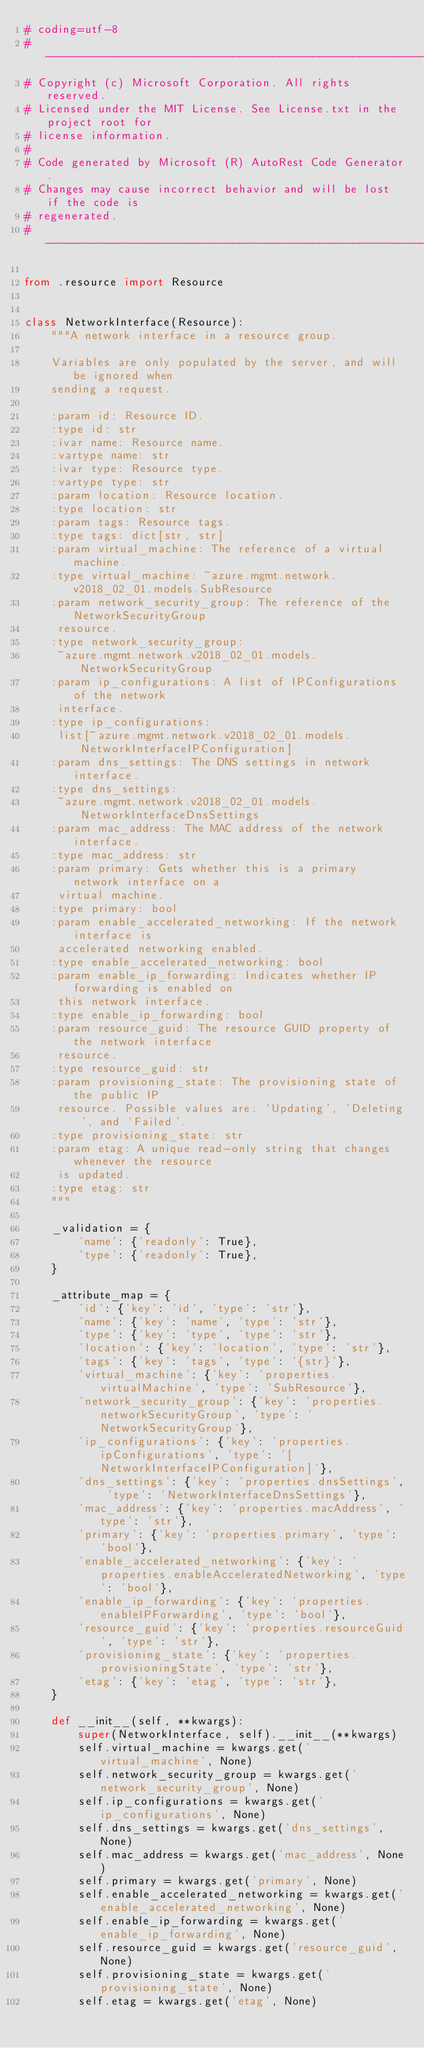Convert code to text. <code><loc_0><loc_0><loc_500><loc_500><_Python_># coding=utf-8
# --------------------------------------------------------------------------
# Copyright (c) Microsoft Corporation. All rights reserved.
# Licensed under the MIT License. See License.txt in the project root for
# license information.
#
# Code generated by Microsoft (R) AutoRest Code Generator.
# Changes may cause incorrect behavior and will be lost if the code is
# regenerated.
# --------------------------------------------------------------------------

from .resource import Resource


class NetworkInterface(Resource):
    """A network interface in a resource group.

    Variables are only populated by the server, and will be ignored when
    sending a request.

    :param id: Resource ID.
    :type id: str
    :ivar name: Resource name.
    :vartype name: str
    :ivar type: Resource type.
    :vartype type: str
    :param location: Resource location.
    :type location: str
    :param tags: Resource tags.
    :type tags: dict[str, str]
    :param virtual_machine: The reference of a virtual machine.
    :type virtual_machine: ~azure.mgmt.network.v2018_02_01.models.SubResource
    :param network_security_group: The reference of the NetworkSecurityGroup
     resource.
    :type network_security_group:
     ~azure.mgmt.network.v2018_02_01.models.NetworkSecurityGroup
    :param ip_configurations: A list of IPConfigurations of the network
     interface.
    :type ip_configurations:
     list[~azure.mgmt.network.v2018_02_01.models.NetworkInterfaceIPConfiguration]
    :param dns_settings: The DNS settings in network interface.
    :type dns_settings:
     ~azure.mgmt.network.v2018_02_01.models.NetworkInterfaceDnsSettings
    :param mac_address: The MAC address of the network interface.
    :type mac_address: str
    :param primary: Gets whether this is a primary network interface on a
     virtual machine.
    :type primary: bool
    :param enable_accelerated_networking: If the network interface is
     accelerated networking enabled.
    :type enable_accelerated_networking: bool
    :param enable_ip_forwarding: Indicates whether IP forwarding is enabled on
     this network interface.
    :type enable_ip_forwarding: bool
    :param resource_guid: The resource GUID property of the network interface
     resource.
    :type resource_guid: str
    :param provisioning_state: The provisioning state of the public IP
     resource. Possible values are: 'Updating', 'Deleting', and 'Failed'.
    :type provisioning_state: str
    :param etag: A unique read-only string that changes whenever the resource
     is updated.
    :type etag: str
    """

    _validation = {
        'name': {'readonly': True},
        'type': {'readonly': True},
    }

    _attribute_map = {
        'id': {'key': 'id', 'type': 'str'},
        'name': {'key': 'name', 'type': 'str'},
        'type': {'key': 'type', 'type': 'str'},
        'location': {'key': 'location', 'type': 'str'},
        'tags': {'key': 'tags', 'type': '{str}'},
        'virtual_machine': {'key': 'properties.virtualMachine', 'type': 'SubResource'},
        'network_security_group': {'key': 'properties.networkSecurityGroup', 'type': 'NetworkSecurityGroup'},
        'ip_configurations': {'key': 'properties.ipConfigurations', 'type': '[NetworkInterfaceIPConfiguration]'},
        'dns_settings': {'key': 'properties.dnsSettings', 'type': 'NetworkInterfaceDnsSettings'},
        'mac_address': {'key': 'properties.macAddress', 'type': 'str'},
        'primary': {'key': 'properties.primary', 'type': 'bool'},
        'enable_accelerated_networking': {'key': 'properties.enableAcceleratedNetworking', 'type': 'bool'},
        'enable_ip_forwarding': {'key': 'properties.enableIPForwarding', 'type': 'bool'},
        'resource_guid': {'key': 'properties.resourceGuid', 'type': 'str'},
        'provisioning_state': {'key': 'properties.provisioningState', 'type': 'str'},
        'etag': {'key': 'etag', 'type': 'str'},
    }

    def __init__(self, **kwargs):
        super(NetworkInterface, self).__init__(**kwargs)
        self.virtual_machine = kwargs.get('virtual_machine', None)
        self.network_security_group = kwargs.get('network_security_group', None)
        self.ip_configurations = kwargs.get('ip_configurations', None)
        self.dns_settings = kwargs.get('dns_settings', None)
        self.mac_address = kwargs.get('mac_address', None)
        self.primary = kwargs.get('primary', None)
        self.enable_accelerated_networking = kwargs.get('enable_accelerated_networking', None)
        self.enable_ip_forwarding = kwargs.get('enable_ip_forwarding', None)
        self.resource_guid = kwargs.get('resource_guid', None)
        self.provisioning_state = kwargs.get('provisioning_state', None)
        self.etag = kwargs.get('etag', None)
</code> 